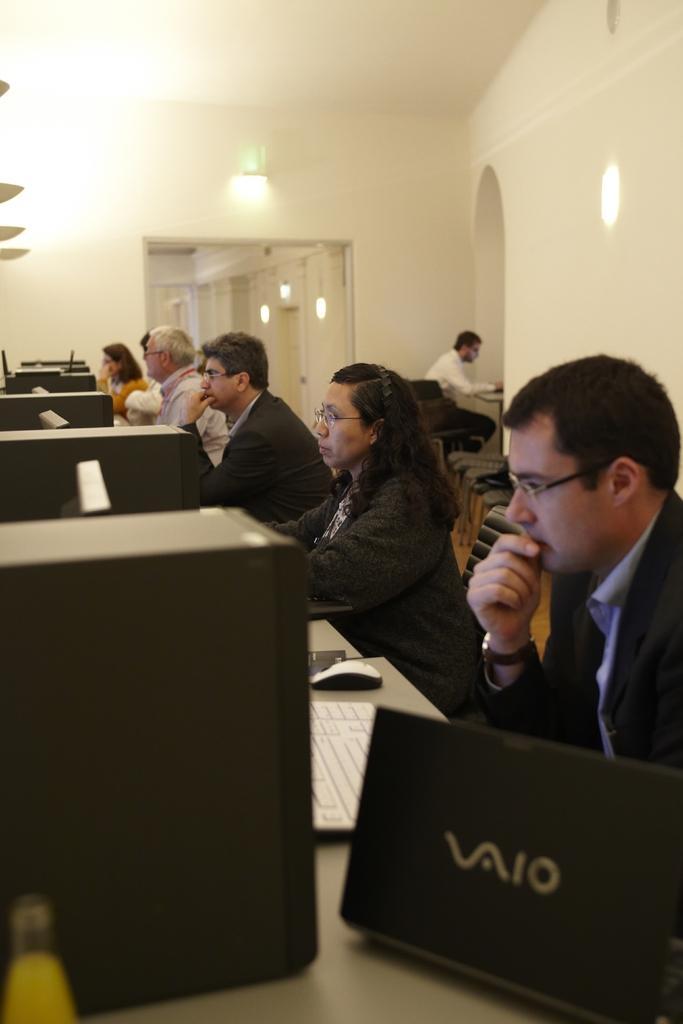Can you describe this image briefly? In the image I can see some people sitting in front of the desk on which there are some systems and also I can see some lights. 